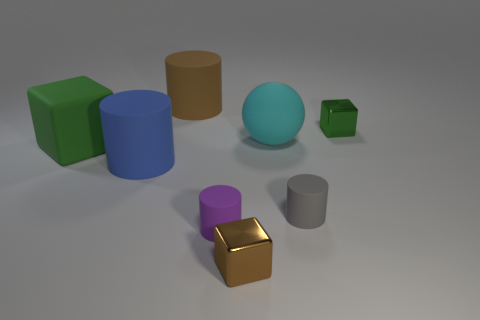Subtract 1 cylinders. How many cylinders are left? 3 Add 1 tiny shiny cubes. How many objects exist? 9 Subtract all spheres. How many objects are left? 7 Subtract all cyan objects. Subtract all tiny cylinders. How many objects are left? 5 Add 4 large green matte blocks. How many large green matte blocks are left? 5 Add 8 purple things. How many purple things exist? 9 Subtract 0 red cubes. How many objects are left? 8 